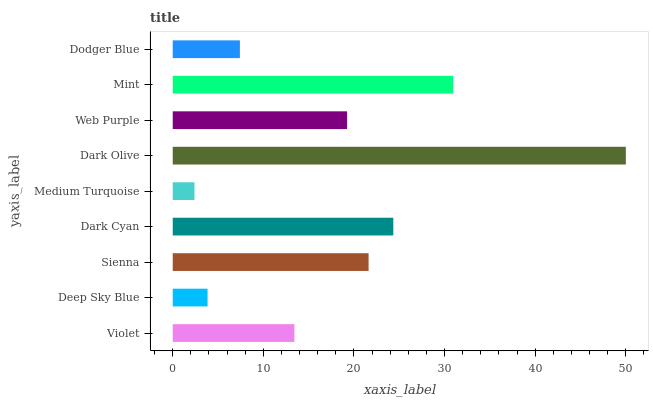Is Medium Turquoise the minimum?
Answer yes or no. Yes. Is Dark Olive the maximum?
Answer yes or no. Yes. Is Deep Sky Blue the minimum?
Answer yes or no. No. Is Deep Sky Blue the maximum?
Answer yes or no. No. Is Violet greater than Deep Sky Blue?
Answer yes or no. Yes. Is Deep Sky Blue less than Violet?
Answer yes or no. Yes. Is Deep Sky Blue greater than Violet?
Answer yes or no. No. Is Violet less than Deep Sky Blue?
Answer yes or no. No. Is Web Purple the high median?
Answer yes or no. Yes. Is Web Purple the low median?
Answer yes or no. Yes. Is Violet the high median?
Answer yes or no. No. Is Dodger Blue the low median?
Answer yes or no. No. 